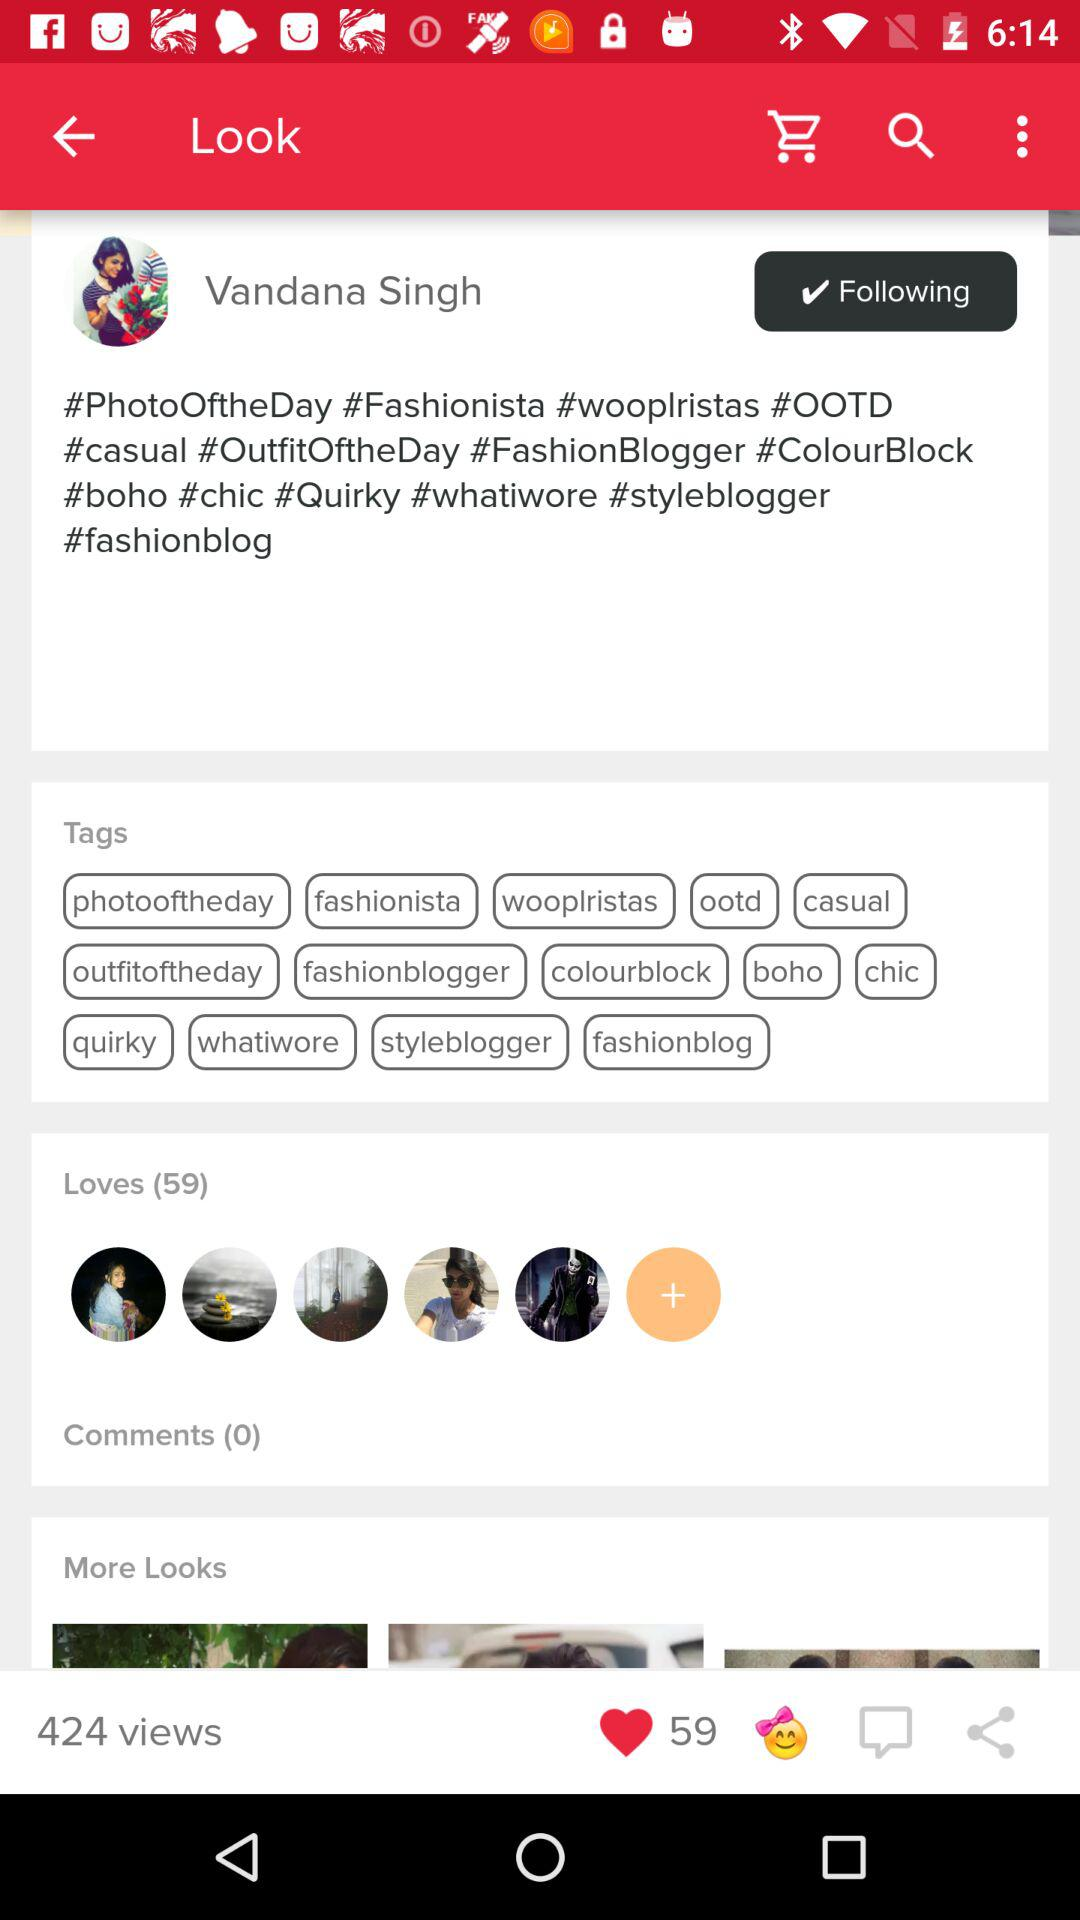How many more loves does this post have than comments?
Answer the question using a single word or phrase. 59 